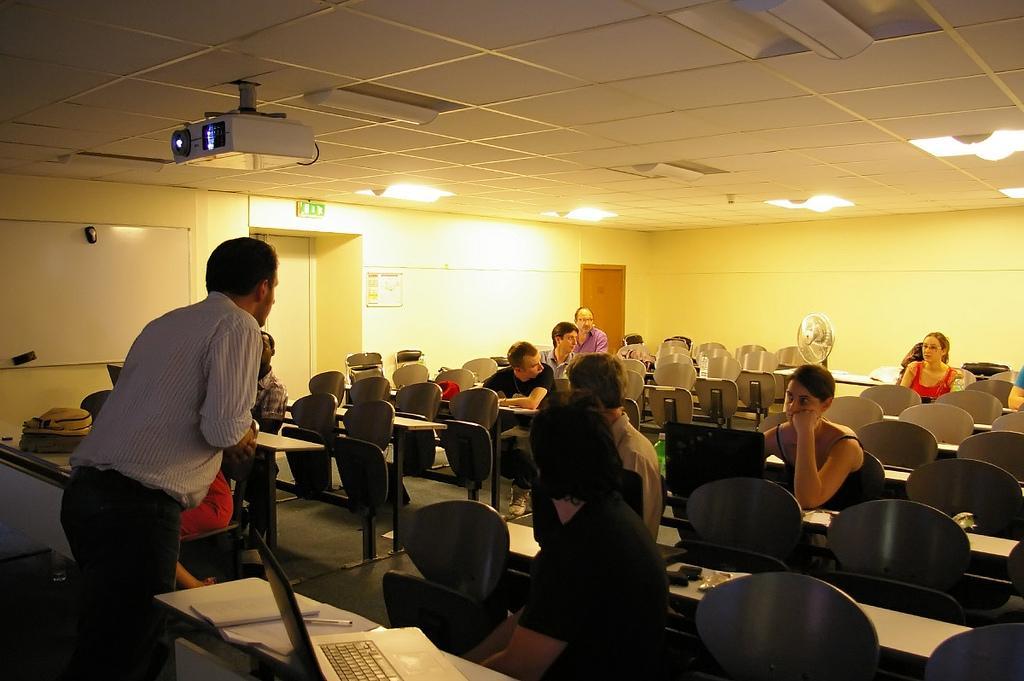In one or two sentences, can you explain what this image depicts? It is a classroom inside the class there are some students sitting on the chairs, in front of them there is a man standing and talking there is a projector to the roof and also some lights,the background there is a fan behind it there is a wall and to left there is a door. 